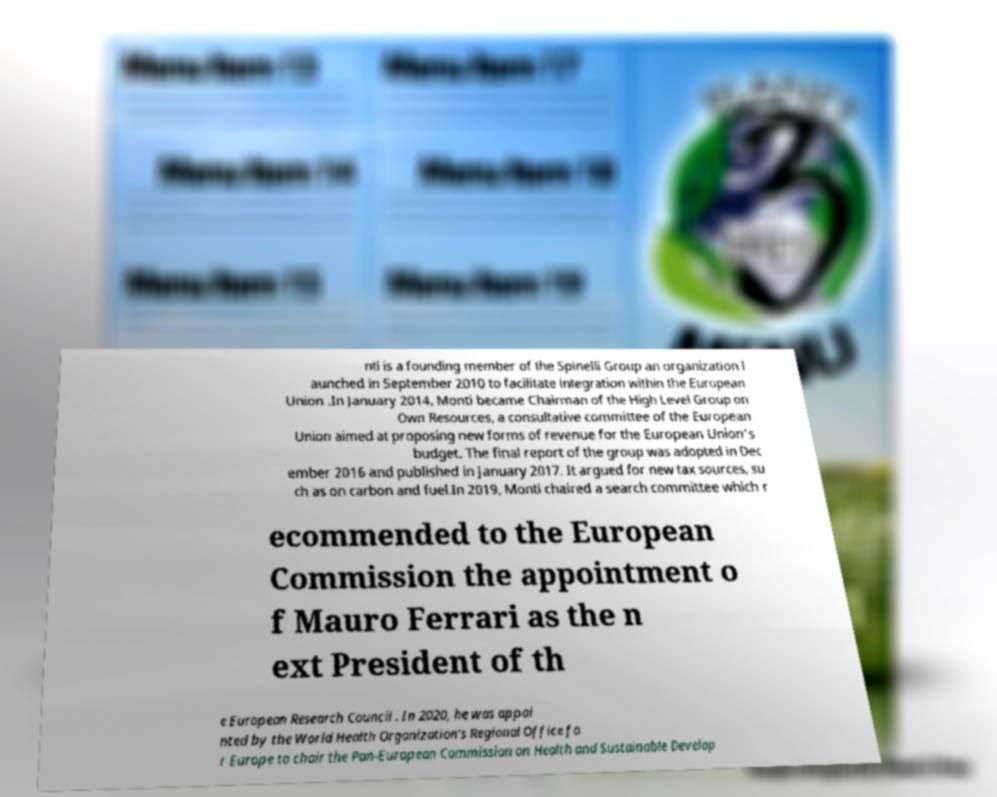Please read and relay the text visible in this image. What does it say? nti is a founding member of the Spinelli Group an organization l aunched in September 2010 to facilitate integration within the European Union .In January 2014, Monti became Chairman of the High Level Group on Own Resources, a consultative committee of the European Union aimed at proposing new forms of revenue for the European Union's budget. The final report of the group was adopted in Dec ember 2016 and published in January 2017. It argued for new tax sources, su ch as on carbon and fuel.In 2019, Monti chaired a search committee which r ecommended to the European Commission the appointment o f Mauro Ferrari as the n ext President of th e European Research Council . In 2020, he was appoi nted by the World Health Organization's Regional Office fo r Europe to chair the Pan-European Commission on Health and Sustainable Develop 